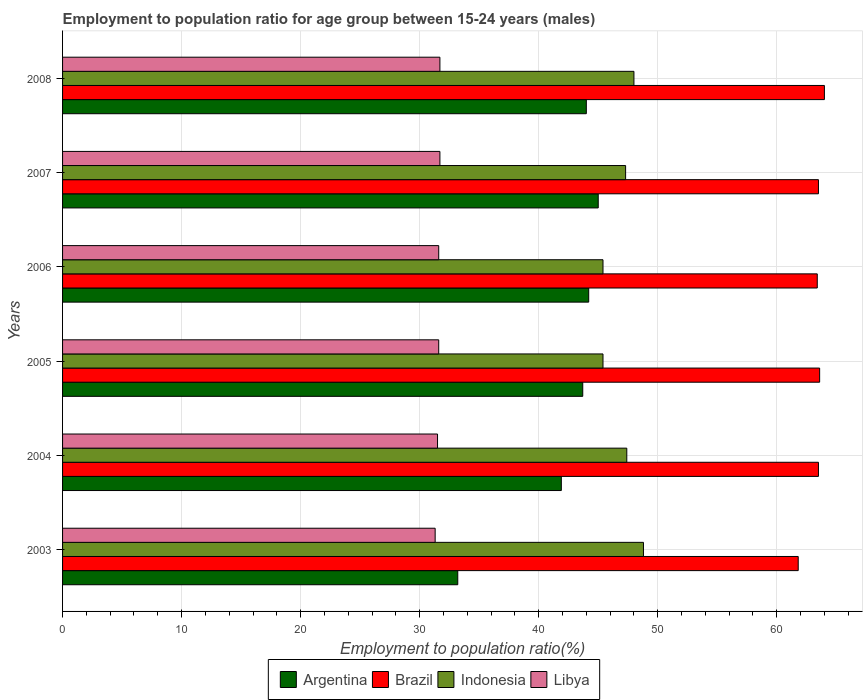How many different coloured bars are there?
Keep it short and to the point. 4. How many groups of bars are there?
Keep it short and to the point. 6. Are the number of bars per tick equal to the number of legend labels?
Offer a terse response. Yes. How many bars are there on the 1st tick from the top?
Your answer should be very brief. 4. What is the label of the 2nd group of bars from the top?
Give a very brief answer. 2007. What is the employment to population ratio in Libya in 2005?
Provide a short and direct response. 31.6. Across all years, what is the minimum employment to population ratio in Libya?
Ensure brevity in your answer.  31.3. In which year was the employment to population ratio in Libya maximum?
Offer a terse response. 2007. What is the total employment to population ratio in Libya in the graph?
Offer a terse response. 189.4. What is the difference between the employment to population ratio in Indonesia in 2004 and that in 2006?
Offer a very short reply. 2. What is the difference between the employment to population ratio in Brazil in 2006 and the employment to population ratio in Indonesia in 2008?
Offer a very short reply. 15.4. What is the average employment to population ratio in Argentina per year?
Provide a succinct answer. 42. In the year 2005, what is the difference between the employment to population ratio in Indonesia and employment to population ratio in Argentina?
Ensure brevity in your answer.  1.7. What is the ratio of the employment to population ratio in Brazil in 2004 to that in 2007?
Offer a terse response. 1. Is the employment to population ratio in Brazil in 2004 less than that in 2007?
Provide a succinct answer. No. Is the difference between the employment to population ratio in Indonesia in 2005 and 2008 greater than the difference between the employment to population ratio in Argentina in 2005 and 2008?
Offer a terse response. No. What is the difference between the highest and the second highest employment to population ratio in Indonesia?
Keep it short and to the point. 0.8. What is the difference between the highest and the lowest employment to population ratio in Indonesia?
Make the answer very short. 3.4. Is it the case that in every year, the sum of the employment to population ratio in Libya and employment to population ratio in Argentina is greater than the sum of employment to population ratio in Brazil and employment to population ratio in Indonesia?
Offer a terse response. No. What does the 3rd bar from the bottom in 2008 represents?
Offer a terse response. Indonesia. Are all the bars in the graph horizontal?
Provide a succinct answer. Yes. Are the values on the major ticks of X-axis written in scientific E-notation?
Your response must be concise. No. Does the graph contain grids?
Provide a succinct answer. Yes. Where does the legend appear in the graph?
Provide a succinct answer. Bottom center. How many legend labels are there?
Provide a succinct answer. 4. How are the legend labels stacked?
Your answer should be compact. Horizontal. What is the title of the graph?
Your answer should be compact. Employment to population ratio for age group between 15-24 years (males). Does "El Salvador" appear as one of the legend labels in the graph?
Make the answer very short. No. What is the label or title of the X-axis?
Provide a succinct answer. Employment to population ratio(%). What is the Employment to population ratio(%) in Argentina in 2003?
Your response must be concise. 33.2. What is the Employment to population ratio(%) in Brazil in 2003?
Offer a terse response. 61.8. What is the Employment to population ratio(%) in Indonesia in 2003?
Ensure brevity in your answer.  48.8. What is the Employment to population ratio(%) of Libya in 2003?
Provide a short and direct response. 31.3. What is the Employment to population ratio(%) in Argentina in 2004?
Provide a succinct answer. 41.9. What is the Employment to population ratio(%) of Brazil in 2004?
Offer a terse response. 63.5. What is the Employment to population ratio(%) of Indonesia in 2004?
Keep it short and to the point. 47.4. What is the Employment to population ratio(%) in Libya in 2004?
Provide a succinct answer. 31.5. What is the Employment to population ratio(%) of Argentina in 2005?
Provide a succinct answer. 43.7. What is the Employment to population ratio(%) in Brazil in 2005?
Your answer should be compact. 63.6. What is the Employment to population ratio(%) of Indonesia in 2005?
Your response must be concise. 45.4. What is the Employment to population ratio(%) in Libya in 2005?
Offer a terse response. 31.6. What is the Employment to population ratio(%) in Argentina in 2006?
Make the answer very short. 44.2. What is the Employment to population ratio(%) in Brazil in 2006?
Provide a succinct answer. 63.4. What is the Employment to population ratio(%) of Indonesia in 2006?
Ensure brevity in your answer.  45.4. What is the Employment to population ratio(%) in Libya in 2006?
Offer a very short reply. 31.6. What is the Employment to population ratio(%) of Argentina in 2007?
Keep it short and to the point. 45. What is the Employment to population ratio(%) in Brazil in 2007?
Make the answer very short. 63.5. What is the Employment to population ratio(%) in Indonesia in 2007?
Ensure brevity in your answer.  47.3. What is the Employment to population ratio(%) of Libya in 2007?
Your response must be concise. 31.7. What is the Employment to population ratio(%) in Brazil in 2008?
Give a very brief answer. 64. What is the Employment to population ratio(%) in Indonesia in 2008?
Offer a terse response. 48. What is the Employment to population ratio(%) of Libya in 2008?
Offer a terse response. 31.7. Across all years, what is the maximum Employment to population ratio(%) in Brazil?
Make the answer very short. 64. Across all years, what is the maximum Employment to population ratio(%) in Indonesia?
Give a very brief answer. 48.8. Across all years, what is the maximum Employment to population ratio(%) of Libya?
Your answer should be compact. 31.7. Across all years, what is the minimum Employment to population ratio(%) in Argentina?
Your answer should be compact. 33.2. Across all years, what is the minimum Employment to population ratio(%) in Brazil?
Provide a short and direct response. 61.8. Across all years, what is the minimum Employment to population ratio(%) of Indonesia?
Your answer should be compact. 45.4. Across all years, what is the minimum Employment to population ratio(%) in Libya?
Your answer should be very brief. 31.3. What is the total Employment to population ratio(%) of Argentina in the graph?
Give a very brief answer. 252. What is the total Employment to population ratio(%) of Brazil in the graph?
Offer a terse response. 379.8. What is the total Employment to population ratio(%) in Indonesia in the graph?
Ensure brevity in your answer.  282.3. What is the total Employment to population ratio(%) in Libya in the graph?
Your answer should be compact. 189.4. What is the difference between the Employment to population ratio(%) of Libya in 2003 and that in 2004?
Give a very brief answer. -0.2. What is the difference between the Employment to population ratio(%) of Indonesia in 2003 and that in 2005?
Offer a terse response. 3.4. What is the difference between the Employment to population ratio(%) of Libya in 2003 and that in 2005?
Your answer should be compact. -0.3. What is the difference between the Employment to population ratio(%) in Brazil in 2003 and that in 2006?
Offer a terse response. -1.6. What is the difference between the Employment to population ratio(%) in Indonesia in 2003 and that in 2006?
Keep it short and to the point. 3.4. What is the difference between the Employment to population ratio(%) in Brazil in 2003 and that in 2007?
Ensure brevity in your answer.  -1.7. What is the difference between the Employment to population ratio(%) of Libya in 2003 and that in 2007?
Provide a short and direct response. -0.4. What is the difference between the Employment to population ratio(%) in Argentina in 2003 and that in 2008?
Ensure brevity in your answer.  -10.8. What is the difference between the Employment to population ratio(%) of Brazil in 2003 and that in 2008?
Provide a short and direct response. -2.2. What is the difference between the Employment to population ratio(%) of Indonesia in 2003 and that in 2008?
Provide a succinct answer. 0.8. What is the difference between the Employment to population ratio(%) of Brazil in 2004 and that in 2005?
Give a very brief answer. -0.1. What is the difference between the Employment to population ratio(%) of Indonesia in 2004 and that in 2005?
Ensure brevity in your answer.  2. What is the difference between the Employment to population ratio(%) of Indonesia in 2004 and that in 2006?
Offer a very short reply. 2. What is the difference between the Employment to population ratio(%) of Libya in 2004 and that in 2006?
Provide a succinct answer. -0.1. What is the difference between the Employment to population ratio(%) in Indonesia in 2004 and that in 2007?
Your answer should be very brief. 0.1. What is the difference between the Employment to population ratio(%) of Argentina in 2004 and that in 2008?
Keep it short and to the point. -2.1. What is the difference between the Employment to population ratio(%) in Libya in 2004 and that in 2008?
Your answer should be compact. -0.2. What is the difference between the Employment to population ratio(%) in Indonesia in 2005 and that in 2006?
Your response must be concise. 0. What is the difference between the Employment to population ratio(%) in Argentina in 2006 and that in 2007?
Offer a very short reply. -0.8. What is the difference between the Employment to population ratio(%) of Indonesia in 2006 and that in 2008?
Give a very brief answer. -2.6. What is the difference between the Employment to population ratio(%) of Libya in 2006 and that in 2008?
Ensure brevity in your answer.  -0.1. What is the difference between the Employment to population ratio(%) in Argentina in 2007 and that in 2008?
Your answer should be very brief. 1. What is the difference between the Employment to population ratio(%) in Argentina in 2003 and the Employment to population ratio(%) in Brazil in 2004?
Provide a succinct answer. -30.3. What is the difference between the Employment to population ratio(%) of Argentina in 2003 and the Employment to population ratio(%) of Indonesia in 2004?
Provide a succinct answer. -14.2. What is the difference between the Employment to population ratio(%) of Argentina in 2003 and the Employment to population ratio(%) of Libya in 2004?
Make the answer very short. 1.7. What is the difference between the Employment to population ratio(%) of Brazil in 2003 and the Employment to population ratio(%) of Indonesia in 2004?
Make the answer very short. 14.4. What is the difference between the Employment to population ratio(%) in Brazil in 2003 and the Employment to population ratio(%) in Libya in 2004?
Your answer should be compact. 30.3. What is the difference between the Employment to population ratio(%) of Argentina in 2003 and the Employment to population ratio(%) of Brazil in 2005?
Your answer should be compact. -30.4. What is the difference between the Employment to population ratio(%) in Argentina in 2003 and the Employment to population ratio(%) in Indonesia in 2005?
Your response must be concise. -12.2. What is the difference between the Employment to population ratio(%) in Brazil in 2003 and the Employment to population ratio(%) in Indonesia in 2005?
Offer a terse response. 16.4. What is the difference between the Employment to population ratio(%) in Brazil in 2003 and the Employment to population ratio(%) in Libya in 2005?
Your answer should be very brief. 30.2. What is the difference between the Employment to population ratio(%) in Indonesia in 2003 and the Employment to population ratio(%) in Libya in 2005?
Keep it short and to the point. 17.2. What is the difference between the Employment to population ratio(%) in Argentina in 2003 and the Employment to population ratio(%) in Brazil in 2006?
Your response must be concise. -30.2. What is the difference between the Employment to population ratio(%) in Argentina in 2003 and the Employment to population ratio(%) in Indonesia in 2006?
Ensure brevity in your answer.  -12.2. What is the difference between the Employment to population ratio(%) of Brazil in 2003 and the Employment to population ratio(%) of Indonesia in 2006?
Keep it short and to the point. 16.4. What is the difference between the Employment to population ratio(%) of Brazil in 2003 and the Employment to population ratio(%) of Libya in 2006?
Your answer should be compact. 30.2. What is the difference between the Employment to population ratio(%) in Argentina in 2003 and the Employment to population ratio(%) in Brazil in 2007?
Offer a very short reply. -30.3. What is the difference between the Employment to population ratio(%) in Argentina in 2003 and the Employment to population ratio(%) in Indonesia in 2007?
Provide a short and direct response. -14.1. What is the difference between the Employment to population ratio(%) in Brazil in 2003 and the Employment to population ratio(%) in Libya in 2007?
Keep it short and to the point. 30.1. What is the difference between the Employment to population ratio(%) in Indonesia in 2003 and the Employment to population ratio(%) in Libya in 2007?
Your answer should be very brief. 17.1. What is the difference between the Employment to population ratio(%) of Argentina in 2003 and the Employment to population ratio(%) of Brazil in 2008?
Keep it short and to the point. -30.8. What is the difference between the Employment to population ratio(%) in Argentina in 2003 and the Employment to population ratio(%) in Indonesia in 2008?
Offer a terse response. -14.8. What is the difference between the Employment to population ratio(%) in Argentina in 2003 and the Employment to population ratio(%) in Libya in 2008?
Offer a terse response. 1.5. What is the difference between the Employment to population ratio(%) of Brazil in 2003 and the Employment to population ratio(%) of Libya in 2008?
Provide a short and direct response. 30.1. What is the difference between the Employment to population ratio(%) in Indonesia in 2003 and the Employment to population ratio(%) in Libya in 2008?
Keep it short and to the point. 17.1. What is the difference between the Employment to population ratio(%) in Argentina in 2004 and the Employment to population ratio(%) in Brazil in 2005?
Keep it short and to the point. -21.7. What is the difference between the Employment to population ratio(%) in Argentina in 2004 and the Employment to population ratio(%) in Libya in 2005?
Make the answer very short. 10.3. What is the difference between the Employment to population ratio(%) of Brazil in 2004 and the Employment to population ratio(%) of Indonesia in 2005?
Offer a terse response. 18.1. What is the difference between the Employment to population ratio(%) of Brazil in 2004 and the Employment to population ratio(%) of Libya in 2005?
Make the answer very short. 31.9. What is the difference between the Employment to population ratio(%) in Indonesia in 2004 and the Employment to population ratio(%) in Libya in 2005?
Provide a succinct answer. 15.8. What is the difference between the Employment to population ratio(%) in Argentina in 2004 and the Employment to population ratio(%) in Brazil in 2006?
Offer a terse response. -21.5. What is the difference between the Employment to population ratio(%) of Brazil in 2004 and the Employment to population ratio(%) of Indonesia in 2006?
Provide a short and direct response. 18.1. What is the difference between the Employment to population ratio(%) of Brazil in 2004 and the Employment to population ratio(%) of Libya in 2006?
Give a very brief answer. 31.9. What is the difference between the Employment to population ratio(%) of Indonesia in 2004 and the Employment to population ratio(%) of Libya in 2006?
Offer a terse response. 15.8. What is the difference between the Employment to population ratio(%) in Argentina in 2004 and the Employment to population ratio(%) in Brazil in 2007?
Offer a terse response. -21.6. What is the difference between the Employment to population ratio(%) in Brazil in 2004 and the Employment to population ratio(%) in Libya in 2007?
Your response must be concise. 31.8. What is the difference between the Employment to population ratio(%) of Indonesia in 2004 and the Employment to population ratio(%) of Libya in 2007?
Provide a succinct answer. 15.7. What is the difference between the Employment to population ratio(%) in Argentina in 2004 and the Employment to population ratio(%) in Brazil in 2008?
Your response must be concise. -22.1. What is the difference between the Employment to population ratio(%) in Argentina in 2004 and the Employment to population ratio(%) in Libya in 2008?
Offer a terse response. 10.2. What is the difference between the Employment to population ratio(%) in Brazil in 2004 and the Employment to population ratio(%) in Indonesia in 2008?
Offer a terse response. 15.5. What is the difference between the Employment to population ratio(%) of Brazil in 2004 and the Employment to population ratio(%) of Libya in 2008?
Keep it short and to the point. 31.8. What is the difference between the Employment to population ratio(%) in Indonesia in 2004 and the Employment to population ratio(%) in Libya in 2008?
Your response must be concise. 15.7. What is the difference between the Employment to population ratio(%) of Argentina in 2005 and the Employment to population ratio(%) of Brazil in 2006?
Your answer should be compact. -19.7. What is the difference between the Employment to population ratio(%) of Argentina in 2005 and the Employment to population ratio(%) of Indonesia in 2006?
Keep it short and to the point. -1.7. What is the difference between the Employment to population ratio(%) of Argentina in 2005 and the Employment to population ratio(%) of Libya in 2006?
Your answer should be very brief. 12.1. What is the difference between the Employment to population ratio(%) in Argentina in 2005 and the Employment to population ratio(%) in Brazil in 2007?
Ensure brevity in your answer.  -19.8. What is the difference between the Employment to population ratio(%) in Argentina in 2005 and the Employment to population ratio(%) in Indonesia in 2007?
Offer a terse response. -3.6. What is the difference between the Employment to population ratio(%) in Argentina in 2005 and the Employment to population ratio(%) in Libya in 2007?
Offer a very short reply. 12. What is the difference between the Employment to population ratio(%) in Brazil in 2005 and the Employment to population ratio(%) in Indonesia in 2007?
Provide a short and direct response. 16.3. What is the difference between the Employment to population ratio(%) of Brazil in 2005 and the Employment to population ratio(%) of Libya in 2007?
Your answer should be compact. 31.9. What is the difference between the Employment to population ratio(%) in Argentina in 2005 and the Employment to population ratio(%) in Brazil in 2008?
Your answer should be very brief. -20.3. What is the difference between the Employment to population ratio(%) of Argentina in 2005 and the Employment to population ratio(%) of Indonesia in 2008?
Provide a short and direct response. -4.3. What is the difference between the Employment to population ratio(%) in Brazil in 2005 and the Employment to population ratio(%) in Indonesia in 2008?
Provide a succinct answer. 15.6. What is the difference between the Employment to population ratio(%) of Brazil in 2005 and the Employment to population ratio(%) of Libya in 2008?
Offer a very short reply. 31.9. What is the difference between the Employment to population ratio(%) in Argentina in 2006 and the Employment to population ratio(%) in Brazil in 2007?
Offer a terse response. -19.3. What is the difference between the Employment to population ratio(%) in Argentina in 2006 and the Employment to population ratio(%) in Libya in 2007?
Make the answer very short. 12.5. What is the difference between the Employment to population ratio(%) of Brazil in 2006 and the Employment to population ratio(%) of Libya in 2007?
Offer a very short reply. 31.7. What is the difference between the Employment to population ratio(%) in Argentina in 2006 and the Employment to population ratio(%) in Brazil in 2008?
Offer a very short reply. -19.8. What is the difference between the Employment to population ratio(%) in Argentina in 2006 and the Employment to population ratio(%) in Libya in 2008?
Make the answer very short. 12.5. What is the difference between the Employment to population ratio(%) in Brazil in 2006 and the Employment to population ratio(%) in Indonesia in 2008?
Give a very brief answer. 15.4. What is the difference between the Employment to population ratio(%) of Brazil in 2006 and the Employment to population ratio(%) of Libya in 2008?
Your response must be concise. 31.7. What is the difference between the Employment to population ratio(%) of Indonesia in 2006 and the Employment to population ratio(%) of Libya in 2008?
Make the answer very short. 13.7. What is the difference between the Employment to population ratio(%) of Argentina in 2007 and the Employment to population ratio(%) of Libya in 2008?
Provide a short and direct response. 13.3. What is the difference between the Employment to population ratio(%) of Brazil in 2007 and the Employment to population ratio(%) of Indonesia in 2008?
Your answer should be very brief. 15.5. What is the difference between the Employment to population ratio(%) in Brazil in 2007 and the Employment to population ratio(%) in Libya in 2008?
Ensure brevity in your answer.  31.8. What is the average Employment to population ratio(%) in Argentina per year?
Make the answer very short. 42. What is the average Employment to population ratio(%) in Brazil per year?
Your answer should be very brief. 63.3. What is the average Employment to population ratio(%) of Indonesia per year?
Keep it short and to the point. 47.05. What is the average Employment to population ratio(%) of Libya per year?
Offer a very short reply. 31.57. In the year 2003, what is the difference between the Employment to population ratio(%) in Argentina and Employment to population ratio(%) in Brazil?
Ensure brevity in your answer.  -28.6. In the year 2003, what is the difference between the Employment to population ratio(%) in Argentina and Employment to population ratio(%) in Indonesia?
Make the answer very short. -15.6. In the year 2003, what is the difference between the Employment to population ratio(%) of Brazil and Employment to population ratio(%) of Indonesia?
Ensure brevity in your answer.  13. In the year 2003, what is the difference between the Employment to population ratio(%) in Brazil and Employment to population ratio(%) in Libya?
Keep it short and to the point. 30.5. In the year 2003, what is the difference between the Employment to population ratio(%) of Indonesia and Employment to population ratio(%) of Libya?
Keep it short and to the point. 17.5. In the year 2004, what is the difference between the Employment to population ratio(%) in Argentina and Employment to population ratio(%) in Brazil?
Provide a succinct answer. -21.6. In the year 2004, what is the difference between the Employment to population ratio(%) in Argentina and Employment to population ratio(%) in Indonesia?
Make the answer very short. -5.5. In the year 2005, what is the difference between the Employment to population ratio(%) of Argentina and Employment to population ratio(%) of Brazil?
Ensure brevity in your answer.  -19.9. In the year 2005, what is the difference between the Employment to population ratio(%) in Argentina and Employment to population ratio(%) in Indonesia?
Ensure brevity in your answer.  -1.7. In the year 2005, what is the difference between the Employment to population ratio(%) of Argentina and Employment to population ratio(%) of Libya?
Make the answer very short. 12.1. In the year 2006, what is the difference between the Employment to population ratio(%) of Argentina and Employment to population ratio(%) of Brazil?
Ensure brevity in your answer.  -19.2. In the year 2006, what is the difference between the Employment to population ratio(%) in Brazil and Employment to population ratio(%) in Indonesia?
Your answer should be compact. 18. In the year 2006, what is the difference between the Employment to population ratio(%) in Brazil and Employment to population ratio(%) in Libya?
Your answer should be compact. 31.8. In the year 2007, what is the difference between the Employment to population ratio(%) of Argentina and Employment to population ratio(%) of Brazil?
Offer a very short reply. -18.5. In the year 2007, what is the difference between the Employment to population ratio(%) in Brazil and Employment to population ratio(%) in Indonesia?
Offer a very short reply. 16.2. In the year 2007, what is the difference between the Employment to population ratio(%) in Brazil and Employment to population ratio(%) in Libya?
Keep it short and to the point. 31.8. In the year 2008, what is the difference between the Employment to population ratio(%) in Argentina and Employment to population ratio(%) in Indonesia?
Provide a succinct answer. -4. In the year 2008, what is the difference between the Employment to population ratio(%) in Argentina and Employment to population ratio(%) in Libya?
Offer a terse response. 12.3. In the year 2008, what is the difference between the Employment to population ratio(%) of Brazil and Employment to population ratio(%) of Libya?
Your response must be concise. 32.3. What is the ratio of the Employment to population ratio(%) of Argentina in 2003 to that in 2004?
Keep it short and to the point. 0.79. What is the ratio of the Employment to population ratio(%) of Brazil in 2003 to that in 2004?
Your answer should be very brief. 0.97. What is the ratio of the Employment to population ratio(%) of Indonesia in 2003 to that in 2004?
Ensure brevity in your answer.  1.03. What is the ratio of the Employment to population ratio(%) of Libya in 2003 to that in 2004?
Offer a terse response. 0.99. What is the ratio of the Employment to population ratio(%) in Argentina in 2003 to that in 2005?
Provide a succinct answer. 0.76. What is the ratio of the Employment to population ratio(%) in Brazil in 2003 to that in 2005?
Keep it short and to the point. 0.97. What is the ratio of the Employment to population ratio(%) in Indonesia in 2003 to that in 2005?
Your answer should be very brief. 1.07. What is the ratio of the Employment to population ratio(%) in Argentina in 2003 to that in 2006?
Your response must be concise. 0.75. What is the ratio of the Employment to population ratio(%) in Brazil in 2003 to that in 2006?
Give a very brief answer. 0.97. What is the ratio of the Employment to population ratio(%) of Indonesia in 2003 to that in 2006?
Your answer should be compact. 1.07. What is the ratio of the Employment to population ratio(%) in Libya in 2003 to that in 2006?
Make the answer very short. 0.99. What is the ratio of the Employment to population ratio(%) in Argentina in 2003 to that in 2007?
Make the answer very short. 0.74. What is the ratio of the Employment to population ratio(%) in Brazil in 2003 to that in 2007?
Give a very brief answer. 0.97. What is the ratio of the Employment to population ratio(%) in Indonesia in 2003 to that in 2007?
Offer a very short reply. 1.03. What is the ratio of the Employment to population ratio(%) of Libya in 2003 to that in 2007?
Offer a terse response. 0.99. What is the ratio of the Employment to population ratio(%) in Argentina in 2003 to that in 2008?
Make the answer very short. 0.75. What is the ratio of the Employment to population ratio(%) of Brazil in 2003 to that in 2008?
Give a very brief answer. 0.97. What is the ratio of the Employment to population ratio(%) in Indonesia in 2003 to that in 2008?
Ensure brevity in your answer.  1.02. What is the ratio of the Employment to population ratio(%) of Libya in 2003 to that in 2008?
Ensure brevity in your answer.  0.99. What is the ratio of the Employment to population ratio(%) in Argentina in 2004 to that in 2005?
Offer a terse response. 0.96. What is the ratio of the Employment to population ratio(%) in Indonesia in 2004 to that in 2005?
Offer a very short reply. 1.04. What is the ratio of the Employment to population ratio(%) in Argentina in 2004 to that in 2006?
Your answer should be very brief. 0.95. What is the ratio of the Employment to population ratio(%) of Indonesia in 2004 to that in 2006?
Your response must be concise. 1.04. What is the ratio of the Employment to population ratio(%) of Libya in 2004 to that in 2006?
Give a very brief answer. 1. What is the ratio of the Employment to population ratio(%) in Argentina in 2004 to that in 2007?
Offer a very short reply. 0.93. What is the ratio of the Employment to population ratio(%) in Indonesia in 2004 to that in 2007?
Your response must be concise. 1. What is the ratio of the Employment to population ratio(%) in Libya in 2004 to that in 2007?
Your answer should be compact. 0.99. What is the ratio of the Employment to population ratio(%) in Argentina in 2004 to that in 2008?
Your answer should be very brief. 0.95. What is the ratio of the Employment to population ratio(%) in Indonesia in 2004 to that in 2008?
Provide a short and direct response. 0.99. What is the ratio of the Employment to population ratio(%) of Argentina in 2005 to that in 2006?
Ensure brevity in your answer.  0.99. What is the ratio of the Employment to population ratio(%) of Brazil in 2005 to that in 2006?
Keep it short and to the point. 1. What is the ratio of the Employment to population ratio(%) of Indonesia in 2005 to that in 2006?
Your answer should be compact. 1. What is the ratio of the Employment to population ratio(%) in Libya in 2005 to that in 2006?
Provide a succinct answer. 1. What is the ratio of the Employment to population ratio(%) of Argentina in 2005 to that in 2007?
Provide a short and direct response. 0.97. What is the ratio of the Employment to population ratio(%) in Brazil in 2005 to that in 2007?
Offer a very short reply. 1. What is the ratio of the Employment to population ratio(%) in Indonesia in 2005 to that in 2007?
Your response must be concise. 0.96. What is the ratio of the Employment to population ratio(%) of Argentina in 2005 to that in 2008?
Your response must be concise. 0.99. What is the ratio of the Employment to population ratio(%) in Brazil in 2005 to that in 2008?
Provide a succinct answer. 0.99. What is the ratio of the Employment to population ratio(%) of Indonesia in 2005 to that in 2008?
Make the answer very short. 0.95. What is the ratio of the Employment to population ratio(%) of Libya in 2005 to that in 2008?
Make the answer very short. 1. What is the ratio of the Employment to population ratio(%) in Argentina in 2006 to that in 2007?
Your answer should be compact. 0.98. What is the ratio of the Employment to population ratio(%) of Brazil in 2006 to that in 2007?
Your response must be concise. 1. What is the ratio of the Employment to population ratio(%) of Indonesia in 2006 to that in 2007?
Your response must be concise. 0.96. What is the ratio of the Employment to population ratio(%) in Argentina in 2006 to that in 2008?
Make the answer very short. 1. What is the ratio of the Employment to population ratio(%) of Brazil in 2006 to that in 2008?
Give a very brief answer. 0.99. What is the ratio of the Employment to population ratio(%) in Indonesia in 2006 to that in 2008?
Provide a succinct answer. 0.95. What is the ratio of the Employment to population ratio(%) of Libya in 2006 to that in 2008?
Keep it short and to the point. 1. What is the ratio of the Employment to population ratio(%) in Argentina in 2007 to that in 2008?
Offer a terse response. 1.02. What is the ratio of the Employment to population ratio(%) in Brazil in 2007 to that in 2008?
Your answer should be very brief. 0.99. What is the ratio of the Employment to population ratio(%) of Indonesia in 2007 to that in 2008?
Provide a succinct answer. 0.99. What is the difference between the highest and the second highest Employment to population ratio(%) in Argentina?
Your answer should be compact. 0.8. What is the difference between the highest and the second highest Employment to population ratio(%) in Libya?
Keep it short and to the point. 0. What is the difference between the highest and the lowest Employment to population ratio(%) of Brazil?
Provide a short and direct response. 2.2. What is the difference between the highest and the lowest Employment to population ratio(%) of Libya?
Keep it short and to the point. 0.4. 